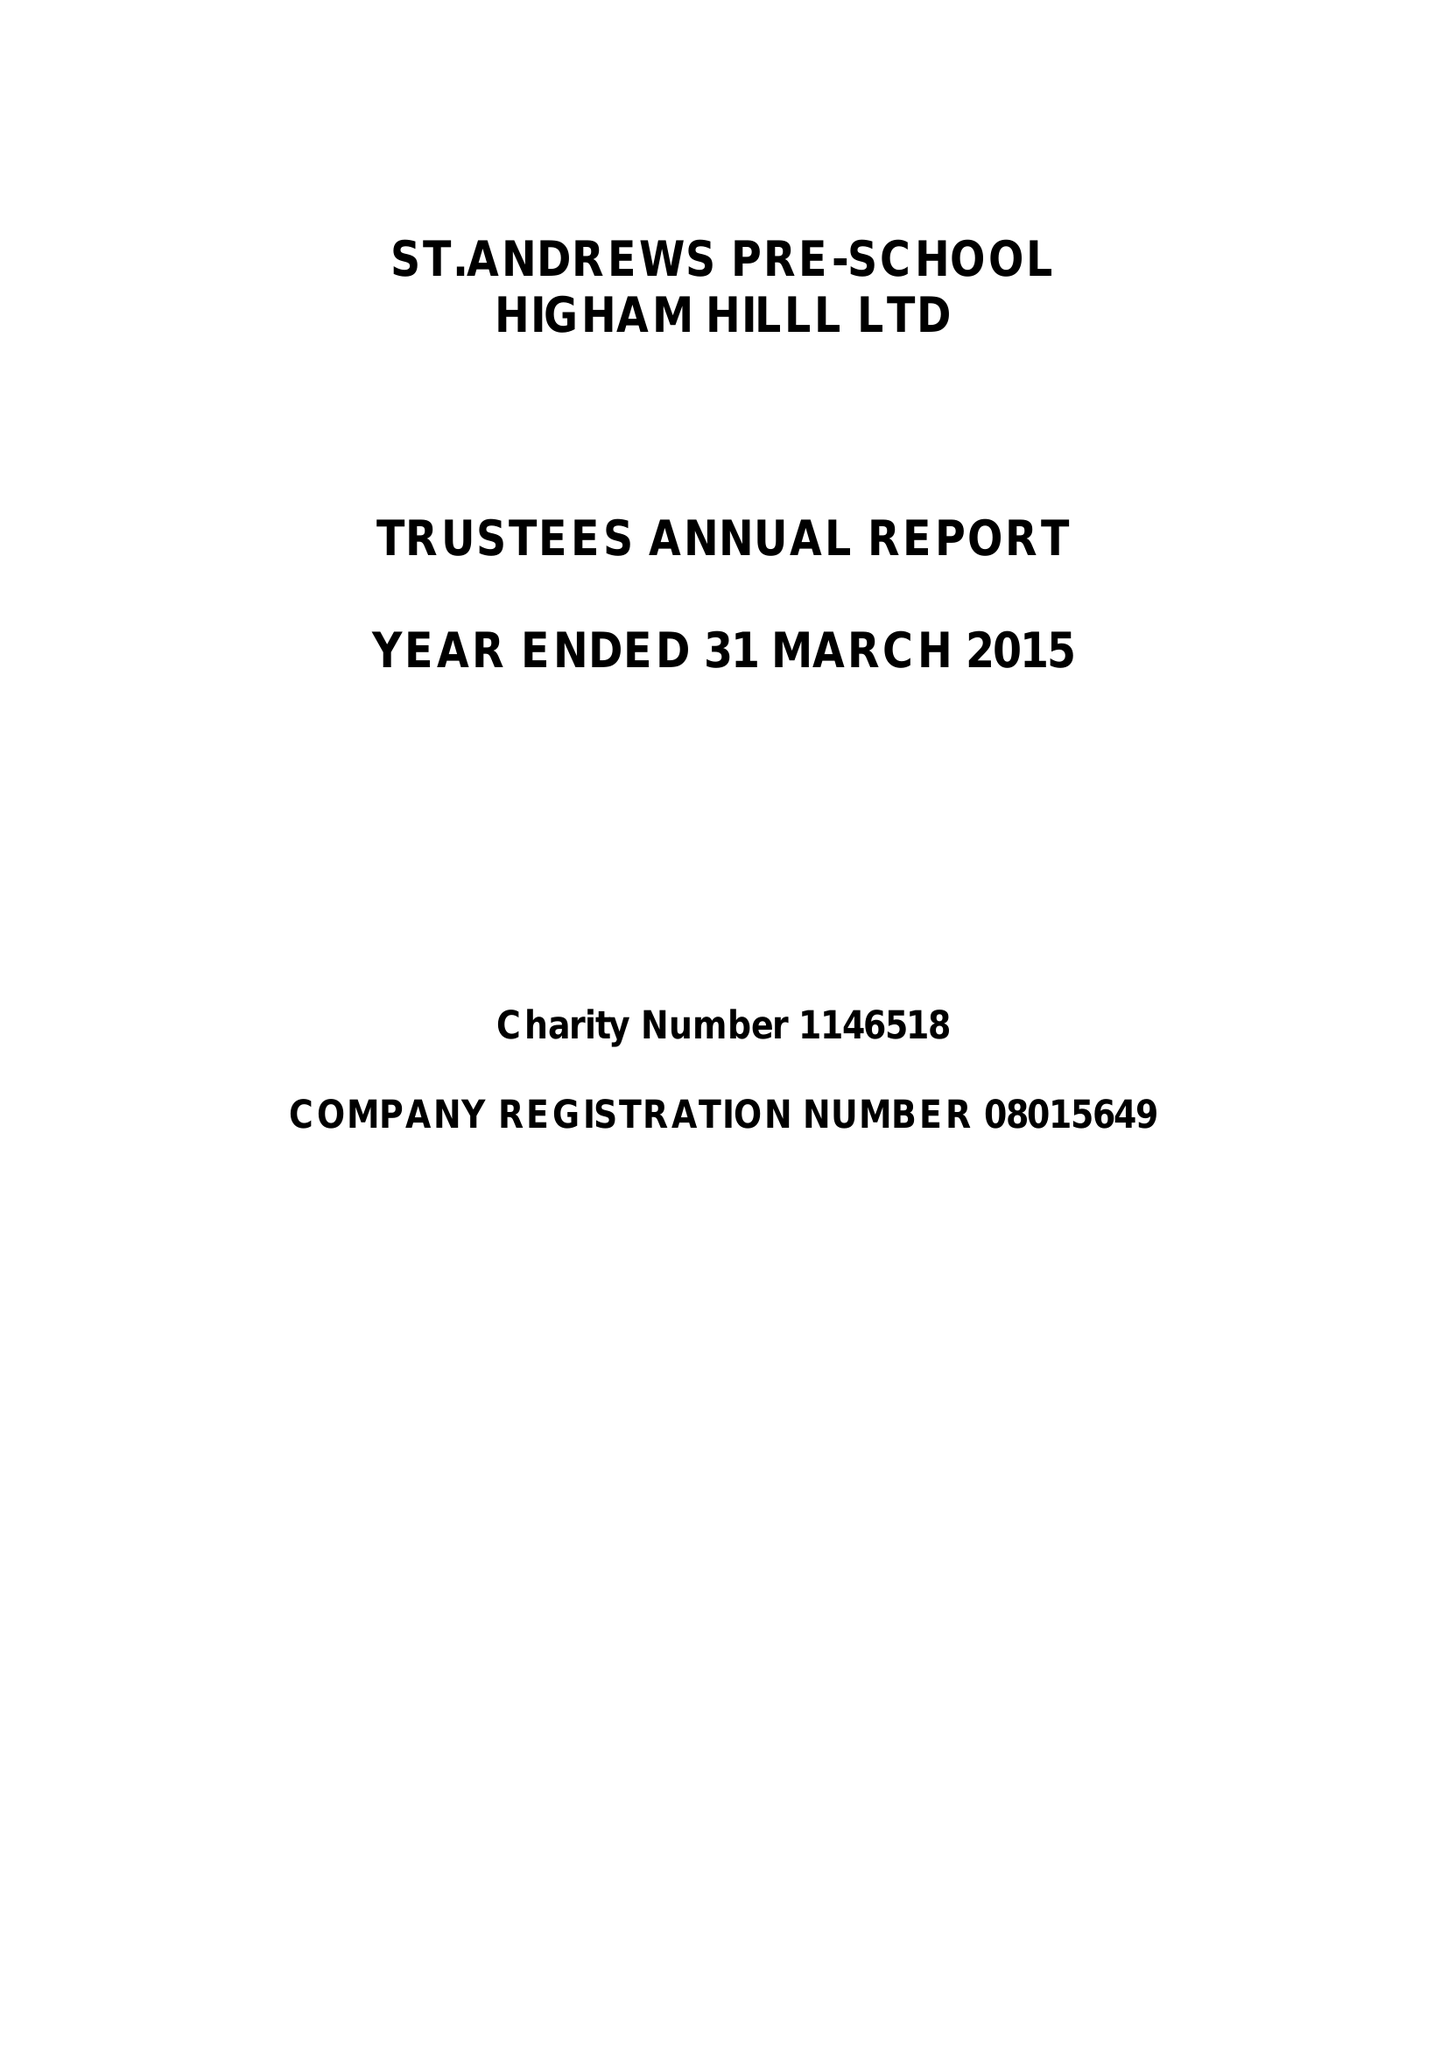What is the value for the address__postcode?
Answer the question using a single word or phrase. E17 6AR 